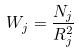<formula> <loc_0><loc_0><loc_500><loc_500>W _ { j } = \frac { N _ { j } } { R _ { j } ^ { 2 } }</formula> 